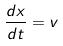<formula> <loc_0><loc_0><loc_500><loc_500>\frac { d x } { d t } = v</formula> 